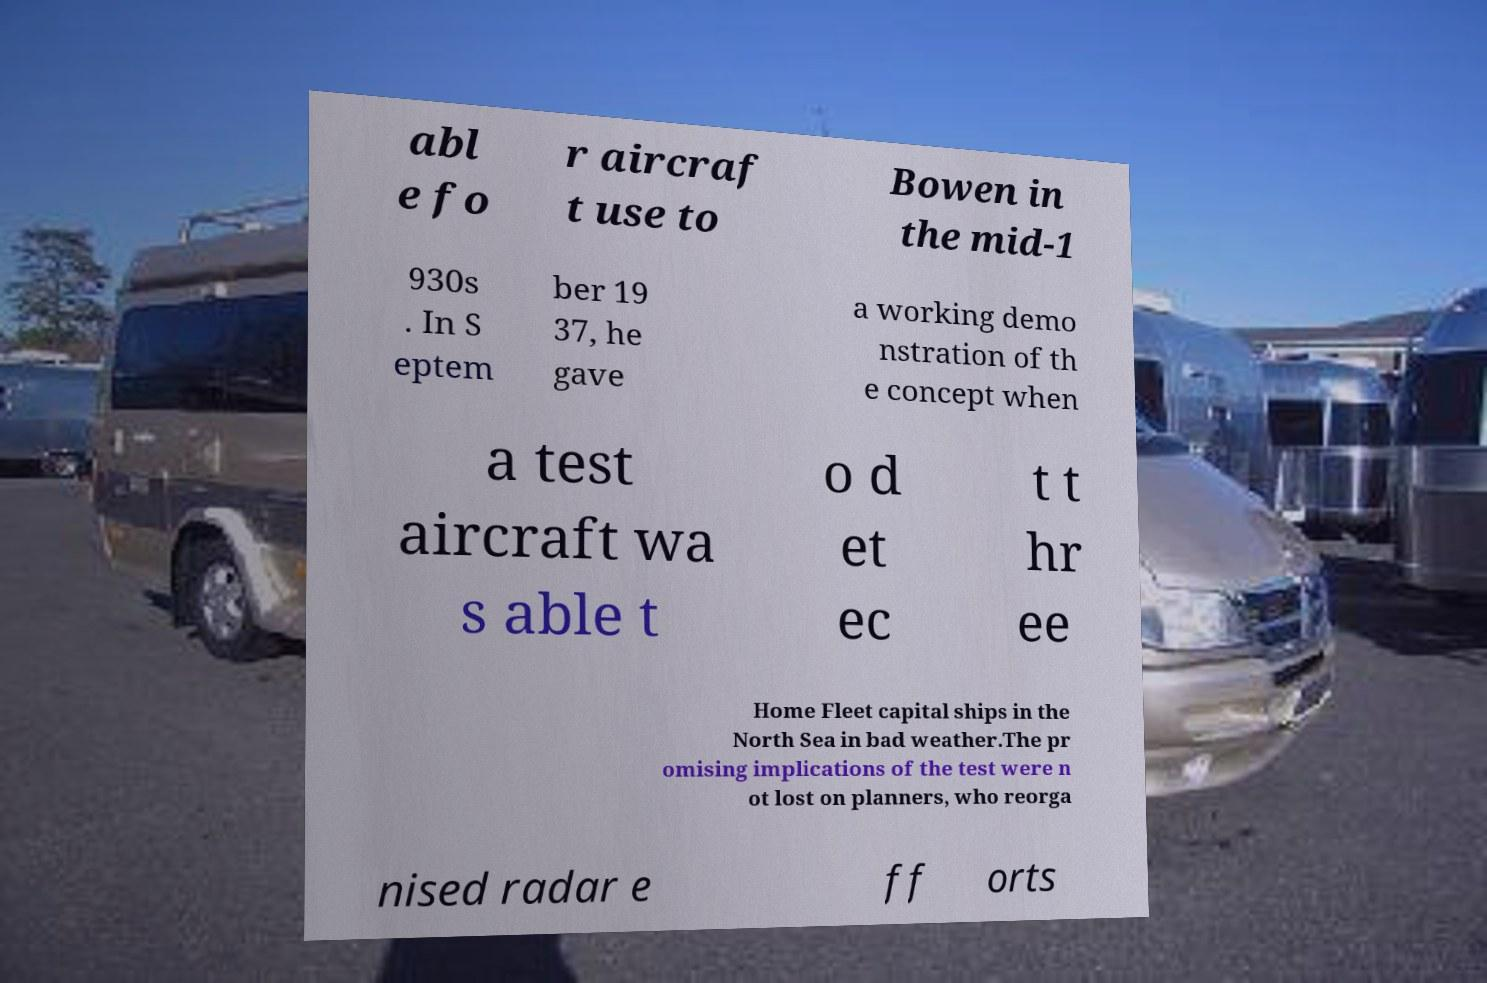Can you read and provide the text displayed in the image?This photo seems to have some interesting text. Can you extract and type it out for me? abl e fo r aircraf t use to Bowen in the mid-1 930s . In S eptem ber 19 37, he gave a working demo nstration of th e concept when a test aircraft wa s able t o d et ec t t hr ee Home Fleet capital ships in the North Sea in bad weather.The pr omising implications of the test were n ot lost on planners, who reorga nised radar e ff orts 